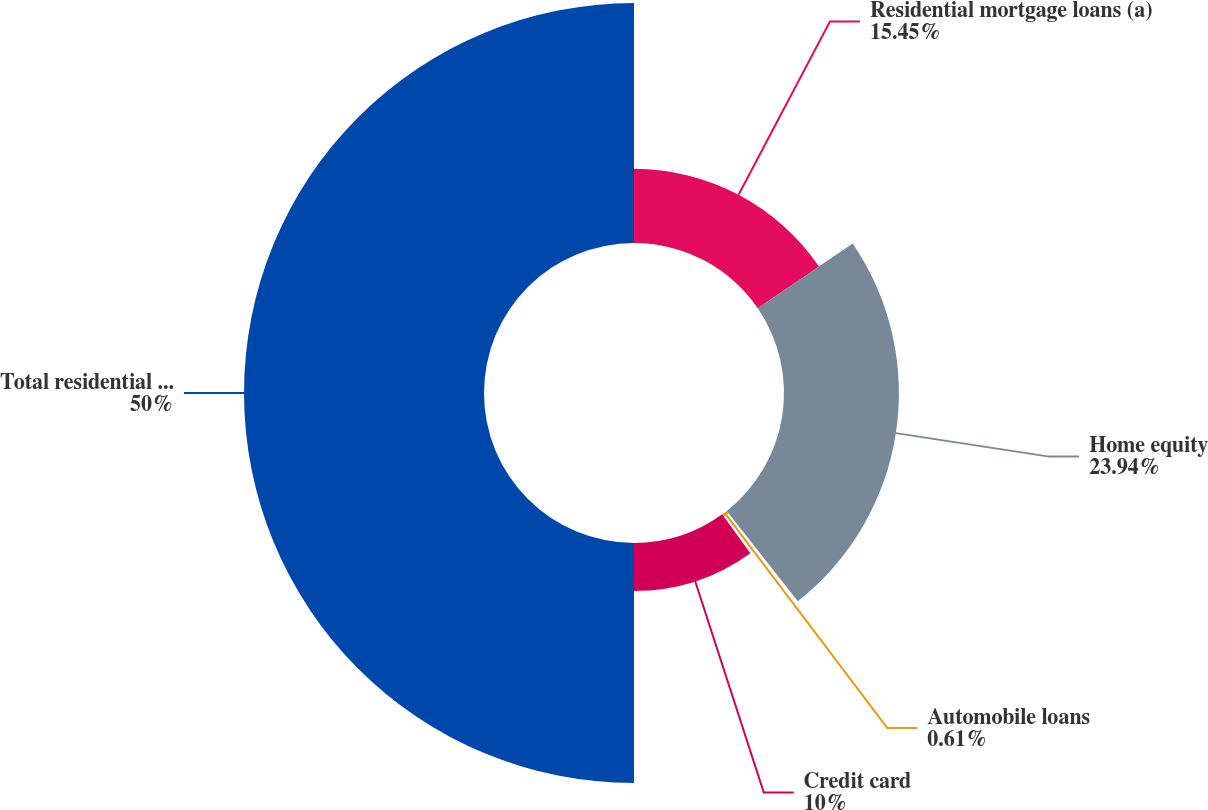Convert chart to OTSL. <chart><loc_0><loc_0><loc_500><loc_500><pie_chart><fcel>Residential mortgage loans (a)<fcel>Home equity<fcel>Automobile loans<fcel>Credit card<fcel>Total residential mortgage and<nl><fcel>15.45%<fcel>23.94%<fcel>0.61%<fcel>10.0%<fcel>50.0%<nl></chart> 